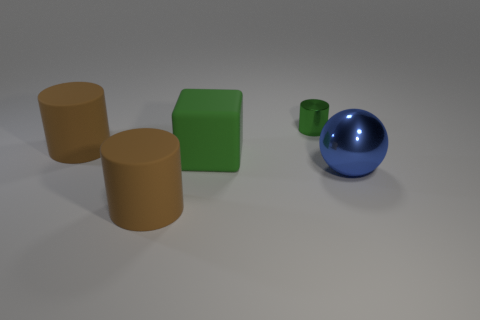Add 5 big green matte cubes. How many objects exist? 10 Subtract all cylinders. How many objects are left? 2 Add 3 large brown rubber objects. How many large brown rubber objects are left? 5 Add 5 tiny cyan metallic balls. How many tiny cyan metallic balls exist? 5 Subtract 0 red blocks. How many objects are left? 5 Subtract all green objects. Subtract all blue metal balls. How many objects are left? 2 